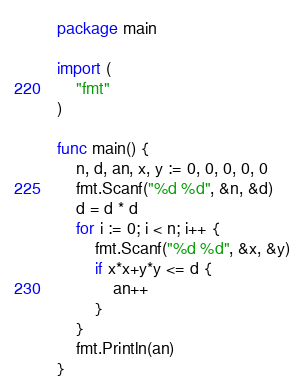Convert code to text. <code><loc_0><loc_0><loc_500><loc_500><_Go_>package main

import (
	"fmt"
)

func main() {
	n, d, an, x, y := 0, 0, 0, 0, 0
	fmt.Scanf("%d %d", &n, &d)
	d = d * d
	for i := 0; i < n; i++ {
		fmt.Scanf("%d %d", &x, &y)
		if x*x+y*y <= d {
			an++
		}
	}
	fmt.Println(an)
}
</code> 